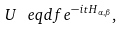<formula> <loc_0><loc_0><loc_500><loc_500>U \ e q d f e ^ { - i t H _ { \alpha , \beta } } ,</formula> 